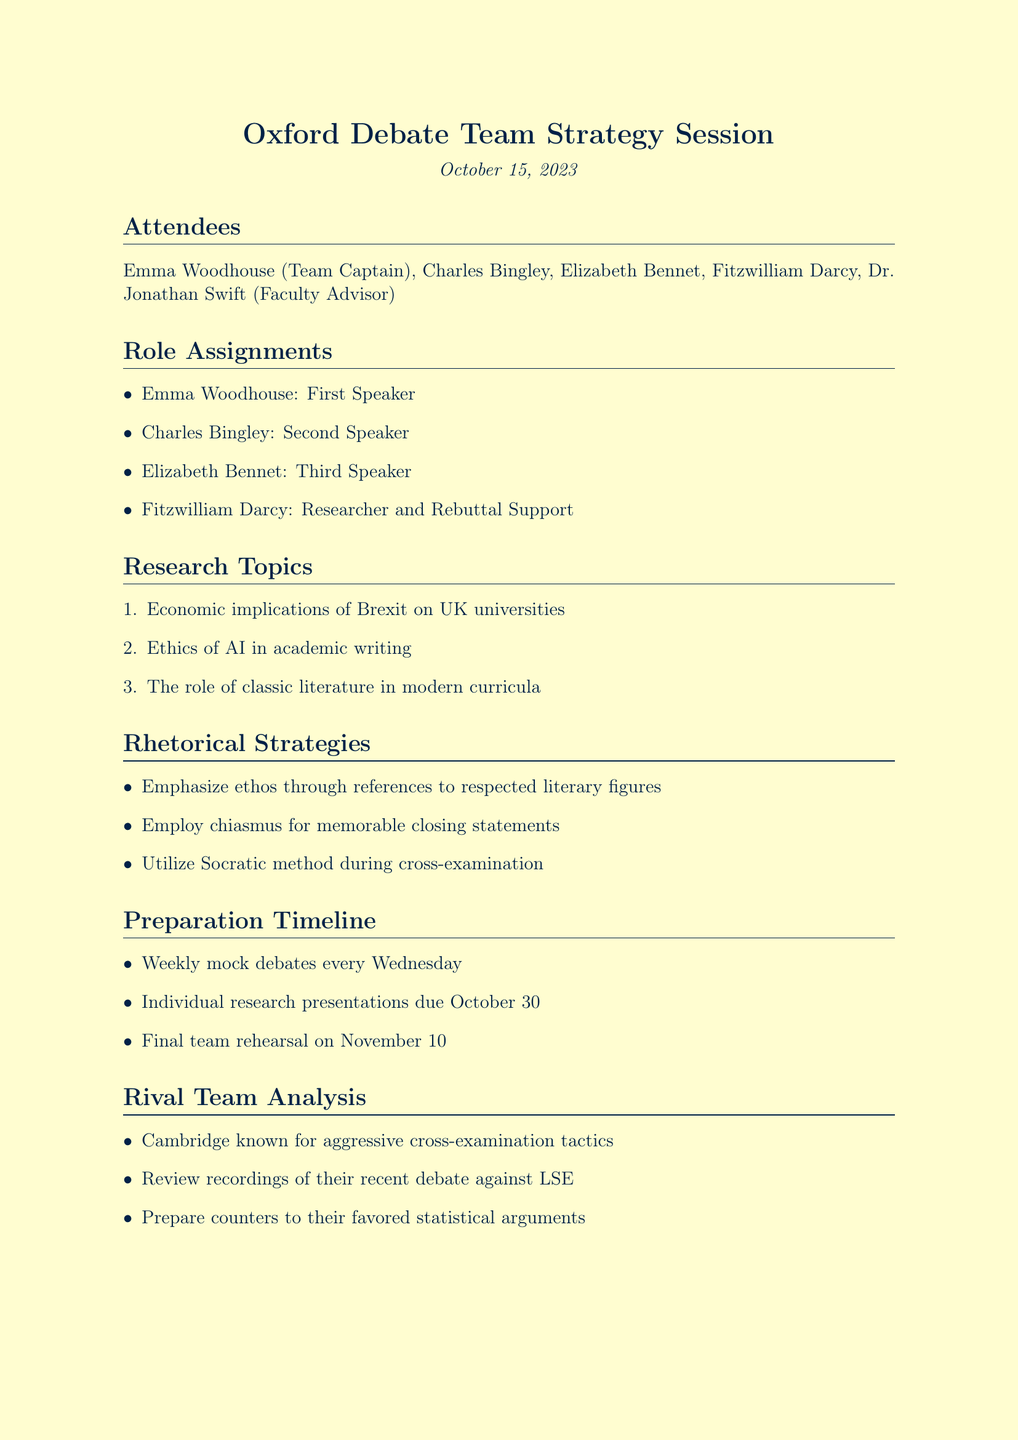What is the date of the meeting? The date is specifically mentioned in the document as the date on which the meeting took place.
Answer: October 15, 2023 Who is the Team Captain? The document lists the attendees and specifies the role of each member, including the Team Captain.
Answer: Emma Woodhouse What role does Fitzwilliam Darcy have? The document outlines the specific roles assigned to each team member, including Fitzwilliam Darcy.
Answer: Researcher and Rebuttal Support How many research topics were assigned? The document provides a list of research topics and their count can be determined by simple enumeration.
Answer: Three What is the next meeting date? The document explicitly states the date and time for the next meeting following this session.
Answer: October 22, 2023 Which rhetorical strategy involves the Socratic method? The document lists various rhetorical strategies and specifies one that uses the Socratic method.
Answer: Utilize Socratic method during cross-examination Who is leading the research on AI ethics? The action items specify who is responsible for researching each topic, including AI ethics.
Answer: Charles What is mentioned about the rival team Cambridge? The document includes analysis of rival teams and provides specific characteristics of one of them.
Answer: Known for aggressive cross-examination tactics 